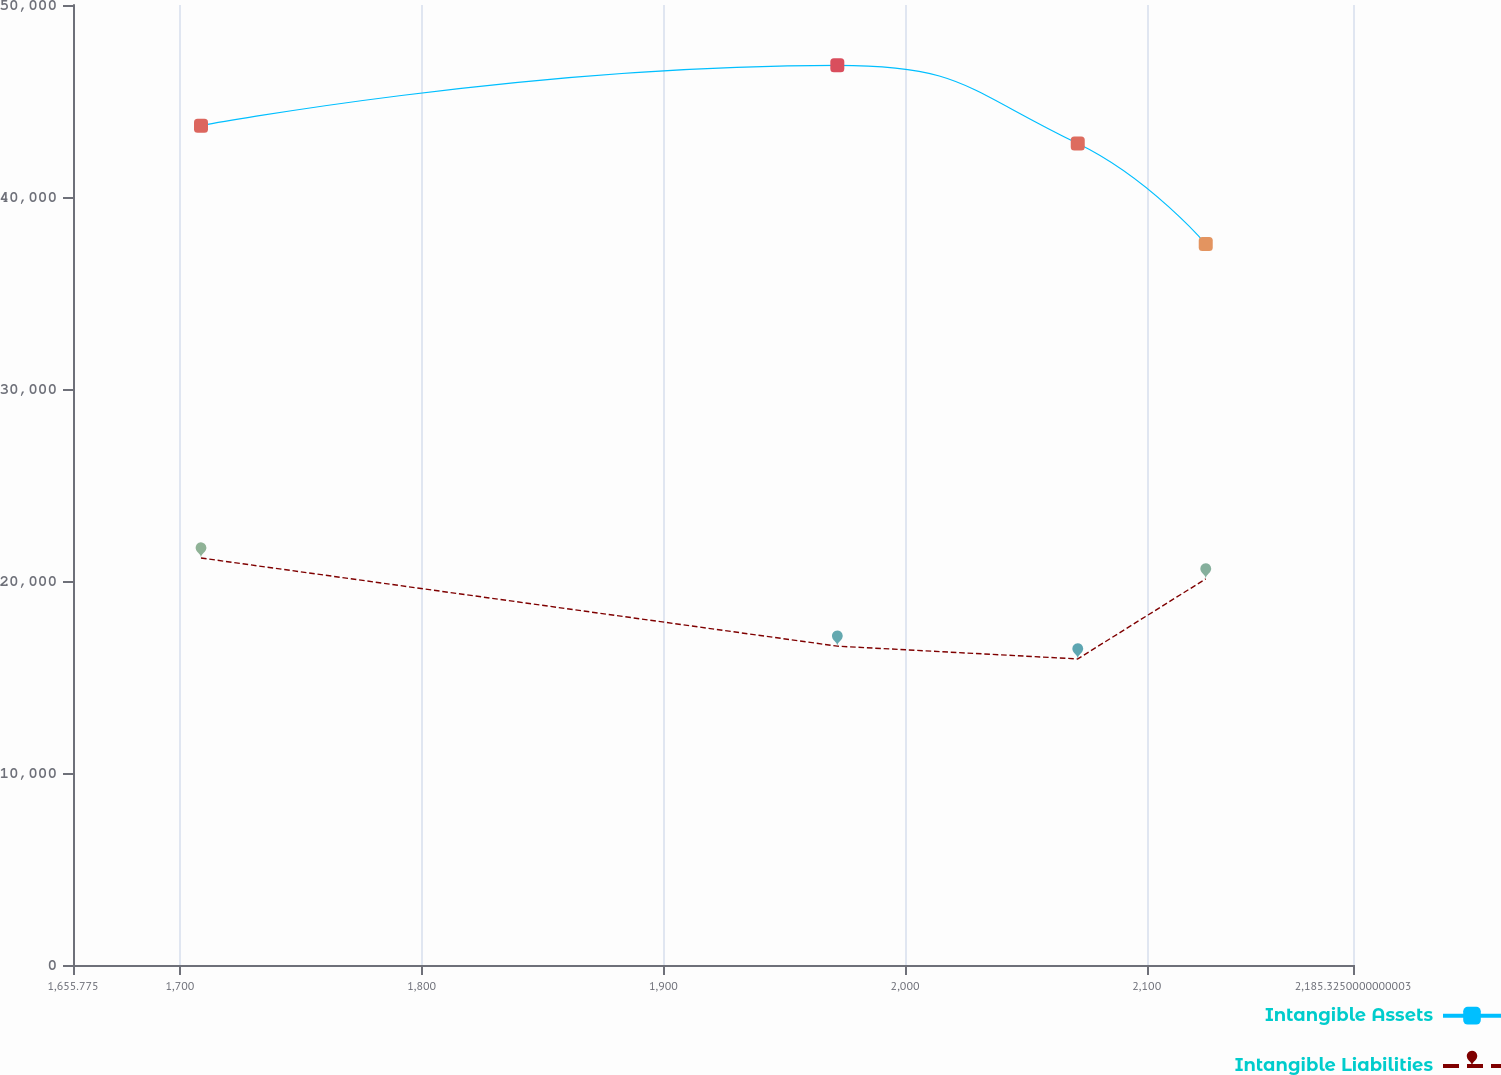Convert chart to OTSL. <chart><loc_0><loc_0><loc_500><loc_500><line_chart><ecel><fcel>Intangible Assets<fcel>Intangible Liabilities<nl><fcel>1708.73<fcel>43717.2<fcel>21197.9<nl><fcel>1971.98<fcel>46857.4<fcel>16606.2<nl><fcel>2071.45<fcel>42786.3<fcel>15941.2<nl><fcel>2124.4<fcel>37548.2<fcel>20109.1<nl><fcel>2238.28<fcel>38479.1<fcel>14548.1<nl></chart> 